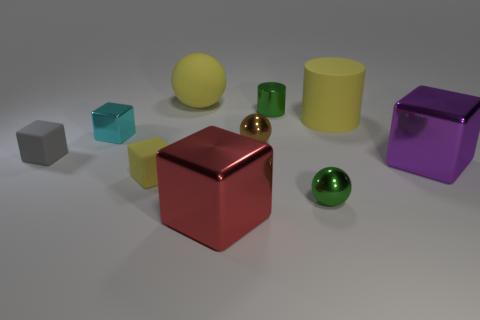Subtract all cyan metallic cubes. How many cubes are left? 4 Subtract all cyan blocks. How many blocks are left? 4 Subtract all green cubes. Subtract all blue spheres. How many cubes are left? 5 Subtract all balls. How many objects are left? 7 Add 7 green blocks. How many green blocks exist? 7 Subtract 1 yellow cubes. How many objects are left? 9 Subtract all tiny rubber cubes. Subtract all green metallic cylinders. How many objects are left? 7 Add 3 brown metal things. How many brown metal things are left? 4 